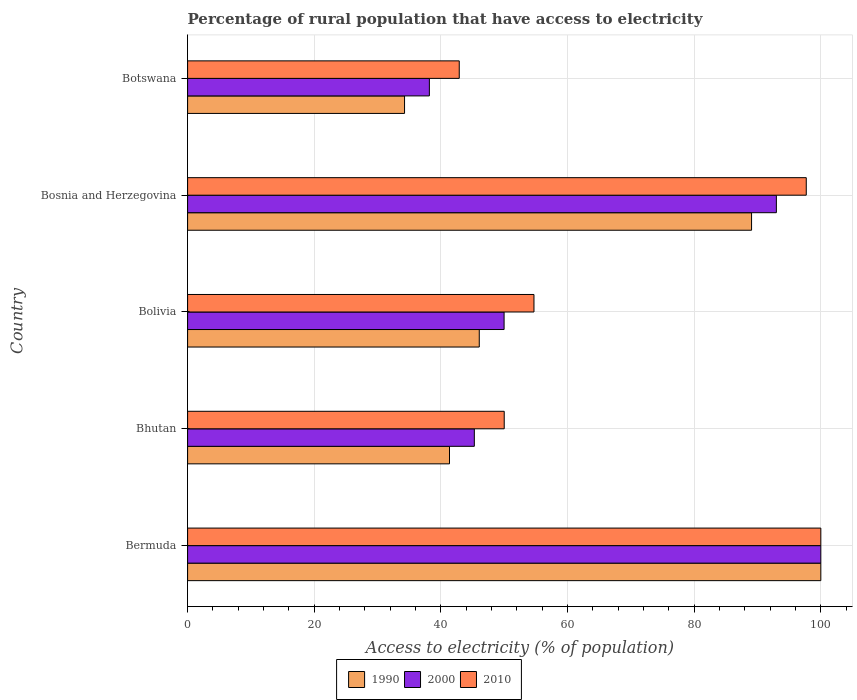How many groups of bars are there?
Keep it short and to the point. 5. Are the number of bars per tick equal to the number of legend labels?
Offer a very short reply. Yes. How many bars are there on the 5th tick from the top?
Make the answer very short. 3. What is the label of the 1st group of bars from the top?
Provide a short and direct response. Botswana. What is the percentage of rural population that have access to electricity in 1990 in Bhutan?
Give a very brief answer. 41.36. Across all countries, what is the maximum percentage of rural population that have access to electricity in 2000?
Provide a succinct answer. 100. Across all countries, what is the minimum percentage of rural population that have access to electricity in 2010?
Offer a very short reply. 42.9. In which country was the percentage of rural population that have access to electricity in 2010 maximum?
Make the answer very short. Bermuda. In which country was the percentage of rural population that have access to electricity in 1990 minimum?
Provide a short and direct response. Botswana. What is the total percentage of rural population that have access to electricity in 2000 in the graph?
Give a very brief answer. 326.42. What is the difference between the percentage of rural population that have access to electricity in 1990 in Bermuda and that in Bosnia and Herzegovina?
Ensure brevity in your answer.  10.94. What is the difference between the percentage of rural population that have access to electricity in 2010 in Bosnia and Herzegovina and the percentage of rural population that have access to electricity in 2000 in Botswana?
Make the answer very short. 59.52. What is the average percentage of rural population that have access to electricity in 2010 per country?
Your answer should be compact. 69.06. What is the difference between the percentage of rural population that have access to electricity in 2000 and percentage of rural population that have access to electricity in 1990 in Bosnia and Herzegovina?
Give a very brief answer. 3.92. In how many countries, is the percentage of rural population that have access to electricity in 1990 greater than 72 %?
Your answer should be very brief. 2. What is the ratio of the percentage of rural population that have access to electricity in 2010 in Bosnia and Herzegovina to that in Botswana?
Offer a terse response. 2.28. Is the difference between the percentage of rural population that have access to electricity in 2000 in Bolivia and Bosnia and Herzegovina greater than the difference between the percentage of rural population that have access to electricity in 1990 in Bolivia and Bosnia and Herzegovina?
Ensure brevity in your answer.  Yes. What is the difference between the highest and the second highest percentage of rural population that have access to electricity in 1990?
Keep it short and to the point. 10.94. What is the difference between the highest and the lowest percentage of rural population that have access to electricity in 2010?
Offer a terse response. 57.1. What does the 1st bar from the top in Bhutan represents?
Make the answer very short. 2010. How many bars are there?
Offer a very short reply. 15. Are all the bars in the graph horizontal?
Your answer should be very brief. Yes. What is the difference between two consecutive major ticks on the X-axis?
Make the answer very short. 20. Are the values on the major ticks of X-axis written in scientific E-notation?
Your answer should be very brief. No. Does the graph contain any zero values?
Ensure brevity in your answer.  No. Does the graph contain grids?
Your response must be concise. Yes. Where does the legend appear in the graph?
Your response must be concise. Bottom center. What is the title of the graph?
Your answer should be very brief. Percentage of rural population that have access to electricity. What is the label or title of the X-axis?
Your answer should be compact. Access to electricity (% of population). What is the Access to electricity (% of population) in 1990 in Bhutan?
Keep it short and to the point. 41.36. What is the Access to electricity (% of population) in 2000 in Bhutan?
Provide a succinct answer. 45.28. What is the Access to electricity (% of population) of 1990 in Bolivia?
Offer a terse response. 46.06. What is the Access to electricity (% of population) in 2000 in Bolivia?
Keep it short and to the point. 49.98. What is the Access to electricity (% of population) of 2010 in Bolivia?
Keep it short and to the point. 54.7. What is the Access to electricity (% of population) in 1990 in Bosnia and Herzegovina?
Keep it short and to the point. 89.06. What is the Access to electricity (% of population) in 2000 in Bosnia and Herzegovina?
Provide a short and direct response. 92.98. What is the Access to electricity (% of population) of 2010 in Bosnia and Herzegovina?
Your response must be concise. 97.7. What is the Access to electricity (% of population) of 1990 in Botswana?
Your answer should be very brief. 34.26. What is the Access to electricity (% of population) in 2000 in Botswana?
Offer a very short reply. 38.18. What is the Access to electricity (% of population) of 2010 in Botswana?
Your response must be concise. 42.9. Across all countries, what is the maximum Access to electricity (% of population) in 2000?
Provide a short and direct response. 100. Across all countries, what is the maximum Access to electricity (% of population) in 2010?
Make the answer very short. 100. Across all countries, what is the minimum Access to electricity (% of population) in 1990?
Keep it short and to the point. 34.26. Across all countries, what is the minimum Access to electricity (% of population) of 2000?
Make the answer very short. 38.18. Across all countries, what is the minimum Access to electricity (% of population) of 2010?
Keep it short and to the point. 42.9. What is the total Access to electricity (% of population) of 1990 in the graph?
Offer a terse response. 310.74. What is the total Access to electricity (% of population) in 2000 in the graph?
Offer a very short reply. 326.42. What is the total Access to electricity (% of population) of 2010 in the graph?
Offer a very short reply. 345.3. What is the difference between the Access to electricity (% of population) of 1990 in Bermuda and that in Bhutan?
Keep it short and to the point. 58.64. What is the difference between the Access to electricity (% of population) of 2000 in Bermuda and that in Bhutan?
Your answer should be compact. 54.72. What is the difference between the Access to electricity (% of population) of 1990 in Bermuda and that in Bolivia?
Your answer should be very brief. 53.94. What is the difference between the Access to electricity (% of population) in 2000 in Bermuda and that in Bolivia?
Give a very brief answer. 50.02. What is the difference between the Access to electricity (% of population) in 2010 in Bermuda and that in Bolivia?
Ensure brevity in your answer.  45.3. What is the difference between the Access to electricity (% of population) of 1990 in Bermuda and that in Bosnia and Herzegovina?
Your response must be concise. 10.94. What is the difference between the Access to electricity (% of population) in 2000 in Bermuda and that in Bosnia and Herzegovina?
Provide a short and direct response. 7.02. What is the difference between the Access to electricity (% of population) of 1990 in Bermuda and that in Botswana?
Provide a succinct answer. 65.74. What is the difference between the Access to electricity (% of population) of 2000 in Bermuda and that in Botswana?
Your answer should be very brief. 61.82. What is the difference between the Access to electricity (% of population) in 2010 in Bermuda and that in Botswana?
Ensure brevity in your answer.  57.1. What is the difference between the Access to electricity (% of population) in 1990 in Bhutan and that in Bolivia?
Provide a short and direct response. -4.7. What is the difference between the Access to electricity (% of population) of 2000 in Bhutan and that in Bolivia?
Ensure brevity in your answer.  -4.7. What is the difference between the Access to electricity (% of population) in 1990 in Bhutan and that in Bosnia and Herzegovina?
Your answer should be very brief. -47.7. What is the difference between the Access to electricity (% of population) of 2000 in Bhutan and that in Bosnia and Herzegovina?
Ensure brevity in your answer.  -47.7. What is the difference between the Access to electricity (% of population) in 2010 in Bhutan and that in Bosnia and Herzegovina?
Provide a short and direct response. -47.7. What is the difference between the Access to electricity (% of population) in 1990 in Bhutan and that in Botswana?
Provide a short and direct response. 7.1. What is the difference between the Access to electricity (% of population) of 2000 in Bhutan and that in Botswana?
Make the answer very short. 7.1. What is the difference between the Access to electricity (% of population) in 2010 in Bhutan and that in Botswana?
Offer a terse response. 7.1. What is the difference between the Access to electricity (% of population) in 1990 in Bolivia and that in Bosnia and Herzegovina?
Your answer should be very brief. -43. What is the difference between the Access to electricity (% of population) of 2000 in Bolivia and that in Bosnia and Herzegovina?
Your response must be concise. -43. What is the difference between the Access to electricity (% of population) in 2010 in Bolivia and that in Bosnia and Herzegovina?
Offer a terse response. -43. What is the difference between the Access to electricity (% of population) in 1990 in Bosnia and Herzegovina and that in Botswana?
Your answer should be very brief. 54.8. What is the difference between the Access to electricity (% of population) of 2000 in Bosnia and Herzegovina and that in Botswana?
Give a very brief answer. 54.8. What is the difference between the Access to electricity (% of population) in 2010 in Bosnia and Herzegovina and that in Botswana?
Provide a succinct answer. 54.8. What is the difference between the Access to electricity (% of population) of 1990 in Bermuda and the Access to electricity (% of population) of 2000 in Bhutan?
Give a very brief answer. 54.72. What is the difference between the Access to electricity (% of population) in 2000 in Bermuda and the Access to electricity (% of population) in 2010 in Bhutan?
Provide a short and direct response. 50. What is the difference between the Access to electricity (% of population) of 1990 in Bermuda and the Access to electricity (% of population) of 2000 in Bolivia?
Ensure brevity in your answer.  50.02. What is the difference between the Access to electricity (% of population) in 1990 in Bermuda and the Access to electricity (% of population) in 2010 in Bolivia?
Give a very brief answer. 45.3. What is the difference between the Access to electricity (% of population) of 2000 in Bermuda and the Access to electricity (% of population) of 2010 in Bolivia?
Provide a short and direct response. 45.3. What is the difference between the Access to electricity (% of population) of 1990 in Bermuda and the Access to electricity (% of population) of 2000 in Bosnia and Herzegovina?
Keep it short and to the point. 7.02. What is the difference between the Access to electricity (% of population) in 1990 in Bermuda and the Access to electricity (% of population) in 2000 in Botswana?
Your answer should be very brief. 61.82. What is the difference between the Access to electricity (% of population) in 1990 in Bermuda and the Access to electricity (% of population) in 2010 in Botswana?
Ensure brevity in your answer.  57.1. What is the difference between the Access to electricity (% of population) of 2000 in Bermuda and the Access to electricity (% of population) of 2010 in Botswana?
Give a very brief answer. 57.1. What is the difference between the Access to electricity (% of population) of 1990 in Bhutan and the Access to electricity (% of population) of 2000 in Bolivia?
Offer a terse response. -8.62. What is the difference between the Access to electricity (% of population) in 1990 in Bhutan and the Access to electricity (% of population) in 2010 in Bolivia?
Ensure brevity in your answer.  -13.34. What is the difference between the Access to electricity (% of population) in 2000 in Bhutan and the Access to electricity (% of population) in 2010 in Bolivia?
Your answer should be compact. -9.42. What is the difference between the Access to electricity (% of population) in 1990 in Bhutan and the Access to electricity (% of population) in 2000 in Bosnia and Herzegovina?
Ensure brevity in your answer.  -51.62. What is the difference between the Access to electricity (% of population) in 1990 in Bhutan and the Access to electricity (% of population) in 2010 in Bosnia and Herzegovina?
Make the answer very short. -56.34. What is the difference between the Access to electricity (% of population) of 2000 in Bhutan and the Access to electricity (% of population) of 2010 in Bosnia and Herzegovina?
Keep it short and to the point. -52.42. What is the difference between the Access to electricity (% of population) in 1990 in Bhutan and the Access to electricity (% of population) in 2000 in Botswana?
Offer a terse response. 3.18. What is the difference between the Access to electricity (% of population) of 1990 in Bhutan and the Access to electricity (% of population) of 2010 in Botswana?
Make the answer very short. -1.54. What is the difference between the Access to electricity (% of population) in 2000 in Bhutan and the Access to electricity (% of population) in 2010 in Botswana?
Keep it short and to the point. 2.38. What is the difference between the Access to electricity (% of population) of 1990 in Bolivia and the Access to electricity (% of population) of 2000 in Bosnia and Herzegovina?
Your answer should be compact. -46.92. What is the difference between the Access to electricity (% of population) of 1990 in Bolivia and the Access to electricity (% of population) of 2010 in Bosnia and Herzegovina?
Give a very brief answer. -51.64. What is the difference between the Access to electricity (% of population) in 2000 in Bolivia and the Access to electricity (% of population) in 2010 in Bosnia and Herzegovina?
Provide a short and direct response. -47.72. What is the difference between the Access to electricity (% of population) in 1990 in Bolivia and the Access to electricity (% of population) in 2000 in Botswana?
Keep it short and to the point. 7.88. What is the difference between the Access to electricity (% of population) in 1990 in Bolivia and the Access to electricity (% of population) in 2010 in Botswana?
Provide a succinct answer. 3.16. What is the difference between the Access to electricity (% of population) in 2000 in Bolivia and the Access to electricity (% of population) in 2010 in Botswana?
Your answer should be compact. 7.08. What is the difference between the Access to electricity (% of population) in 1990 in Bosnia and Herzegovina and the Access to electricity (% of population) in 2000 in Botswana?
Your answer should be very brief. 50.88. What is the difference between the Access to electricity (% of population) of 1990 in Bosnia and Herzegovina and the Access to electricity (% of population) of 2010 in Botswana?
Your response must be concise. 46.16. What is the difference between the Access to electricity (% of population) of 2000 in Bosnia and Herzegovina and the Access to electricity (% of population) of 2010 in Botswana?
Offer a very short reply. 50.08. What is the average Access to electricity (% of population) of 1990 per country?
Give a very brief answer. 62.15. What is the average Access to electricity (% of population) of 2000 per country?
Your answer should be compact. 65.28. What is the average Access to electricity (% of population) in 2010 per country?
Keep it short and to the point. 69.06. What is the difference between the Access to electricity (% of population) in 1990 and Access to electricity (% of population) in 2000 in Bhutan?
Offer a very short reply. -3.92. What is the difference between the Access to electricity (% of population) of 1990 and Access to electricity (% of population) of 2010 in Bhutan?
Provide a short and direct response. -8.64. What is the difference between the Access to electricity (% of population) in 2000 and Access to electricity (% of population) in 2010 in Bhutan?
Your answer should be compact. -4.72. What is the difference between the Access to electricity (% of population) of 1990 and Access to electricity (% of population) of 2000 in Bolivia?
Provide a short and direct response. -3.92. What is the difference between the Access to electricity (% of population) of 1990 and Access to electricity (% of population) of 2010 in Bolivia?
Your response must be concise. -8.64. What is the difference between the Access to electricity (% of population) in 2000 and Access to electricity (% of population) in 2010 in Bolivia?
Provide a succinct answer. -4.72. What is the difference between the Access to electricity (% of population) of 1990 and Access to electricity (% of population) of 2000 in Bosnia and Herzegovina?
Keep it short and to the point. -3.92. What is the difference between the Access to electricity (% of population) in 1990 and Access to electricity (% of population) in 2010 in Bosnia and Herzegovina?
Offer a very short reply. -8.64. What is the difference between the Access to electricity (% of population) in 2000 and Access to electricity (% of population) in 2010 in Bosnia and Herzegovina?
Keep it short and to the point. -4.72. What is the difference between the Access to electricity (% of population) of 1990 and Access to electricity (% of population) of 2000 in Botswana?
Give a very brief answer. -3.92. What is the difference between the Access to electricity (% of population) in 1990 and Access to electricity (% of population) in 2010 in Botswana?
Make the answer very short. -8.64. What is the difference between the Access to electricity (% of population) in 2000 and Access to electricity (% of population) in 2010 in Botswana?
Your answer should be very brief. -4.72. What is the ratio of the Access to electricity (% of population) in 1990 in Bermuda to that in Bhutan?
Your response must be concise. 2.42. What is the ratio of the Access to electricity (% of population) in 2000 in Bermuda to that in Bhutan?
Provide a short and direct response. 2.21. What is the ratio of the Access to electricity (% of population) of 2010 in Bermuda to that in Bhutan?
Your response must be concise. 2. What is the ratio of the Access to electricity (% of population) of 1990 in Bermuda to that in Bolivia?
Your response must be concise. 2.17. What is the ratio of the Access to electricity (% of population) in 2000 in Bermuda to that in Bolivia?
Your answer should be compact. 2. What is the ratio of the Access to electricity (% of population) of 2010 in Bermuda to that in Bolivia?
Provide a short and direct response. 1.83. What is the ratio of the Access to electricity (% of population) of 1990 in Bermuda to that in Bosnia and Herzegovina?
Keep it short and to the point. 1.12. What is the ratio of the Access to electricity (% of population) in 2000 in Bermuda to that in Bosnia and Herzegovina?
Offer a terse response. 1.08. What is the ratio of the Access to electricity (% of population) of 2010 in Bermuda to that in Bosnia and Herzegovina?
Make the answer very short. 1.02. What is the ratio of the Access to electricity (% of population) in 1990 in Bermuda to that in Botswana?
Provide a succinct answer. 2.92. What is the ratio of the Access to electricity (% of population) of 2000 in Bermuda to that in Botswana?
Ensure brevity in your answer.  2.62. What is the ratio of the Access to electricity (% of population) in 2010 in Bermuda to that in Botswana?
Provide a succinct answer. 2.33. What is the ratio of the Access to electricity (% of population) in 1990 in Bhutan to that in Bolivia?
Your answer should be compact. 0.9. What is the ratio of the Access to electricity (% of population) of 2000 in Bhutan to that in Bolivia?
Your answer should be compact. 0.91. What is the ratio of the Access to electricity (% of population) of 2010 in Bhutan to that in Bolivia?
Your answer should be compact. 0.91. What is the ratio of the Access to electricity (% of population) of 1990 in Bhutan to that in Bosnia and Herzegovina?
Ensure brevity in your answer.  0.46. What is the ratio of the Access to electricity (% of population) in 2000 in Bhutan to that in Bosnia and Herzegovina?
Keep it short and to the point. 0.49. What is the ratio of the Access to electricity (% of population) of 2010 in Bhutan to that in Bosnia and Herzegovina?
Offer a very short reply. 0.51. What is the ratio of the Access to electricity (% of population) in 1990 in Bhutan to that in Botswana?
Your answer should be compact. 1.21. What is the ratio of the Access to electricity (% of population) of 2000 in Bhutan to that in Botswana?
Make the answer very short. 1.19. What is the ratio of the Access to electricity (% of population) of 2010 in Bhutan to that in Botswana?
Offer a very short reply. 1.17. What is the ratio of the Access to electricity (% of population) in 1990 in Bolivia to that in Bosnia and Herzegovina?
Your answer should be very brief. 0.52. What is the ratio of the Access to electricity (% of population) in 2000 in Bolivia to that in Bosnia and Herzegovina?
Provide a succinct answer. 0.54. What is the ratio of the Access to electricity (% of population) in 2010 in Bolivia to that in Bosnia and Herzegovina?
Provide a short and direct response. 0.56. What is the ratio of the Access to electricity (% of population) of 1990 in Bolivia to that in Botswana?
Make the answer very short. 1.34. What is the ratio of the Access to electricity (% of population) of 2000 in Bolivia to that in Botswana?
Your response must be concise. 1.31. What is the ratio of the Access to electricity (% of population) of 2010 in Bolivia to that in Botswana?
Provide a succinct answer. 1.28. What is the ratio of the Access to electricity (% of population) in 1990 in Bosnia and Herzegovina to that in Botswana?
Your answer should be very brief. 2.6. What is the ratio of the Access to electricity (% of population) of 2000 in Bosnia and Herzegovina to that in Botswana?
Your response must be concise. 2.44. What is the ratio of the Access to electricity (% of population) in 2010 in Bosnia and Herzegovina to that in Botswana?
Ensure brevity in your answer.  2.28. What is the difference between the highest and the second highest Access to electricity (% of population) in 1990?
Your answer should be very brief. 10.94. What is the difference between the highest and the second highest Access to electricity (% of population) in 2000?
Your response must be concise. 7.02. What is the difference between the highest and the second highest Access to electricity (% of population) of 2010?
Your answer should be very brief. 2.3. What is the difference between the highest and the lowest Access to electricity (% of population) in 1990?
Offer a very short reply. 65.74. What is the difference between the highest and the lowest Access to electricity (% of population) in 2000?
Your answer should be compact. 61.82. What is the difference between the highest and the lowest Access to electricity (% of population) of 2010?
Provide a short and direct response. 57.1. 